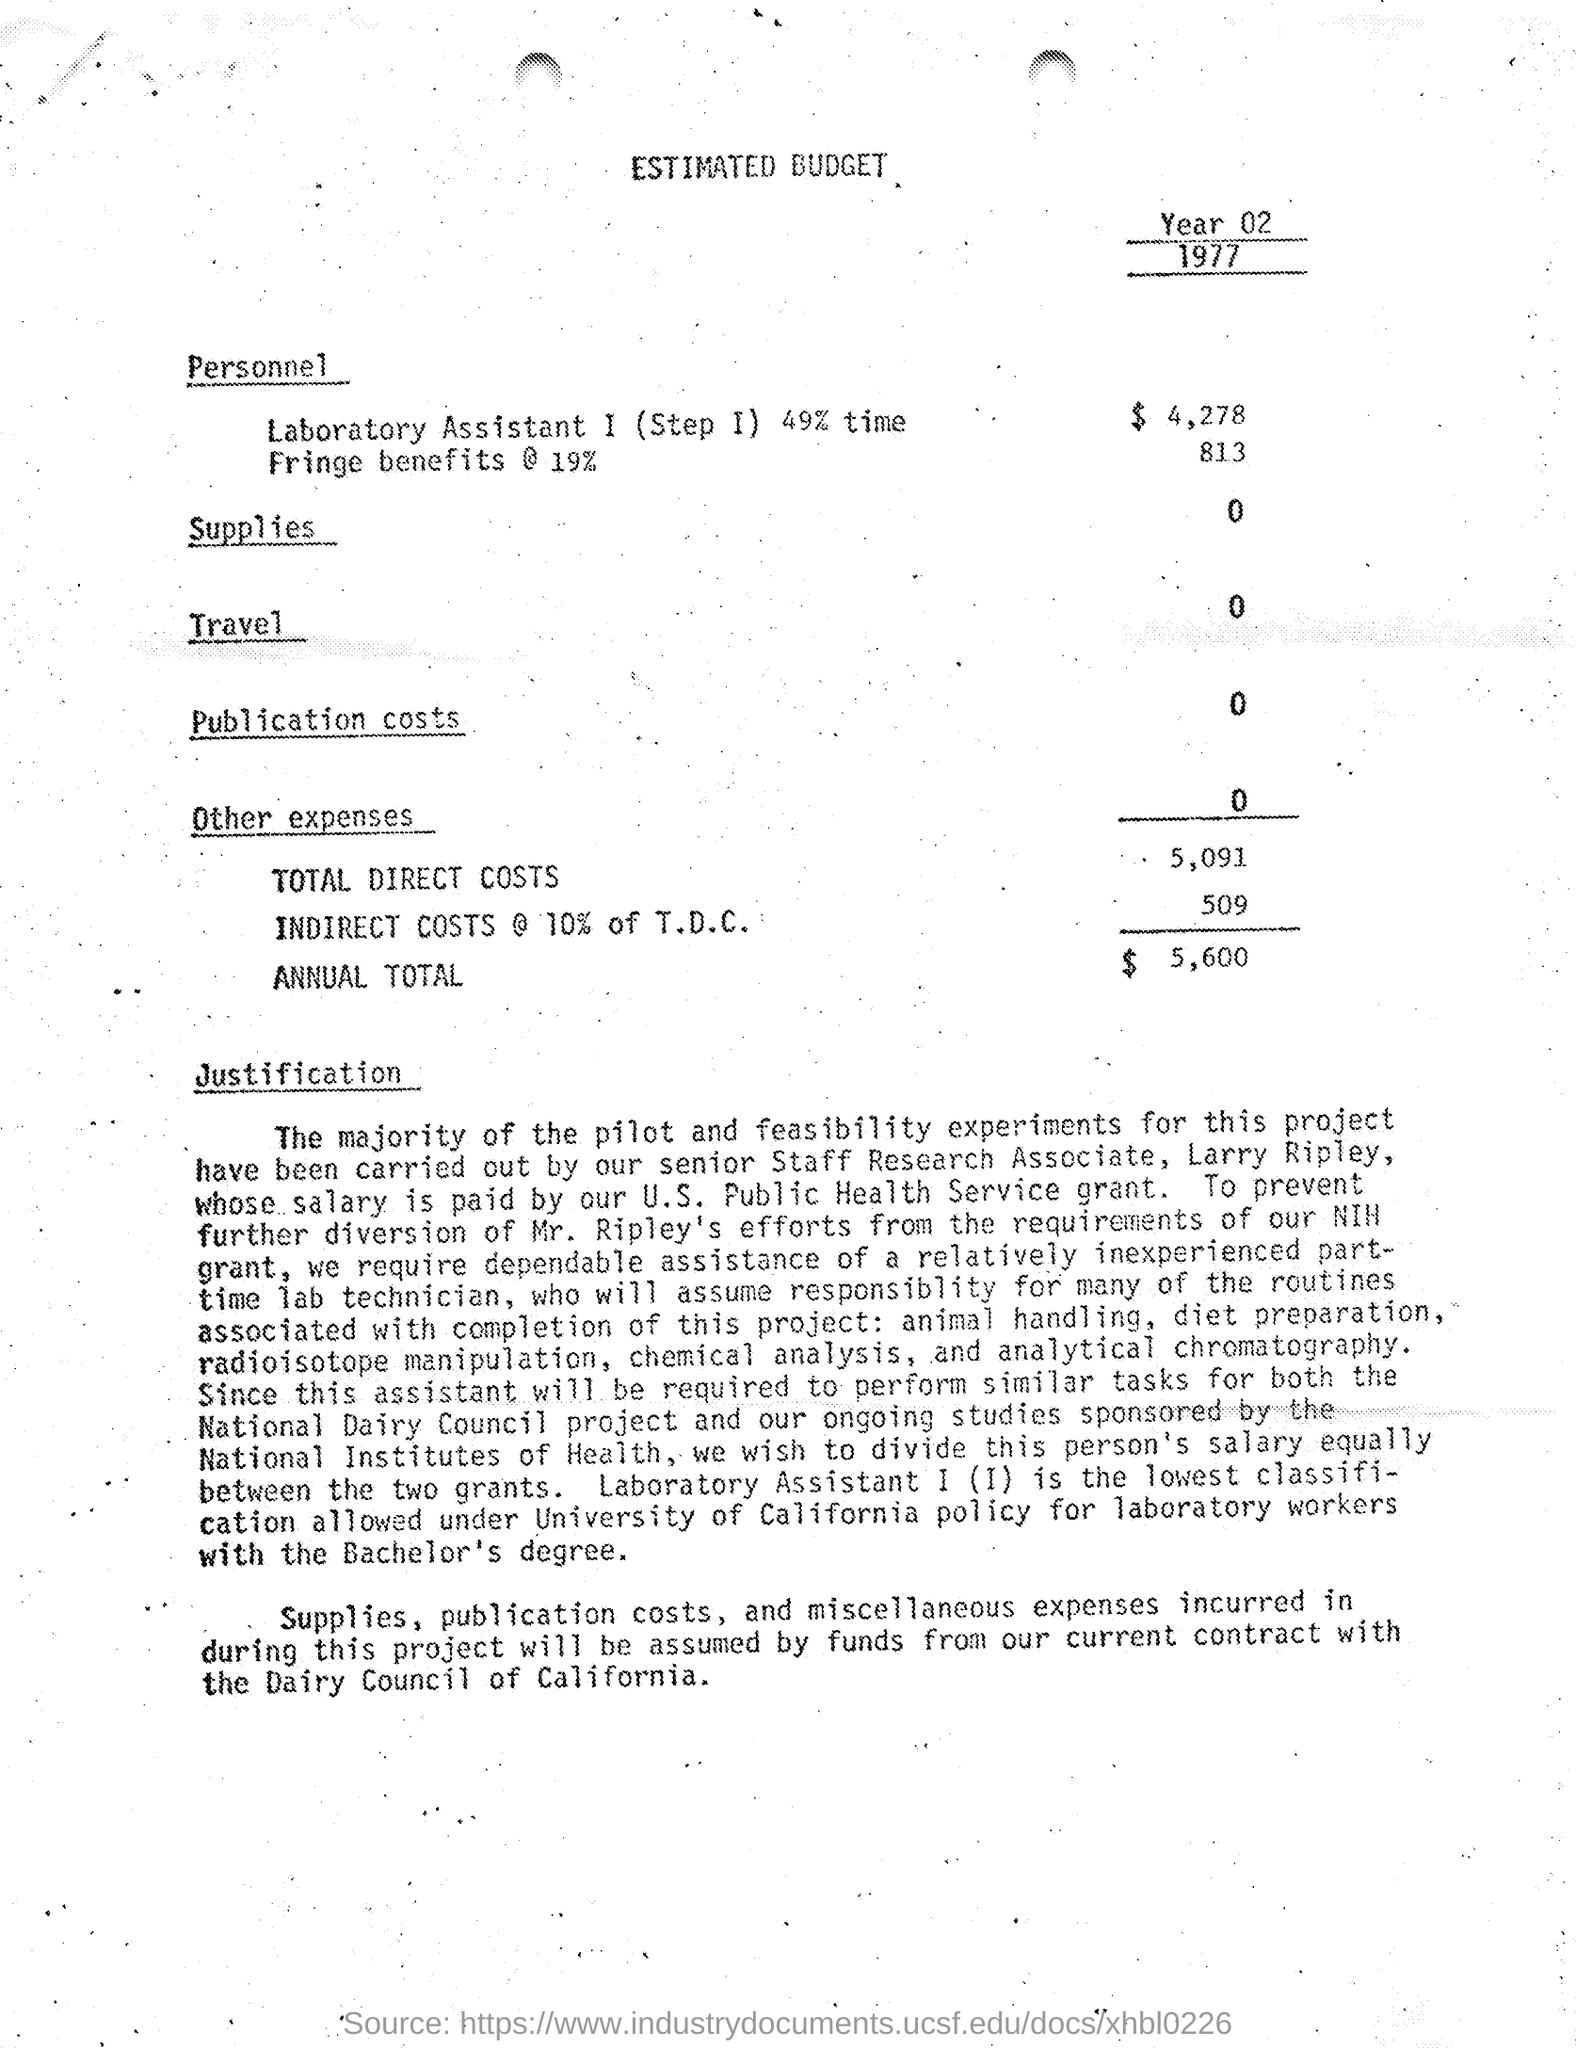What year is this budget for, and can you tell me the total annual cost? The budget is for the year 1977, as noted at the top right corner. The 'ANNUAL TOTAL' is $5,600. 